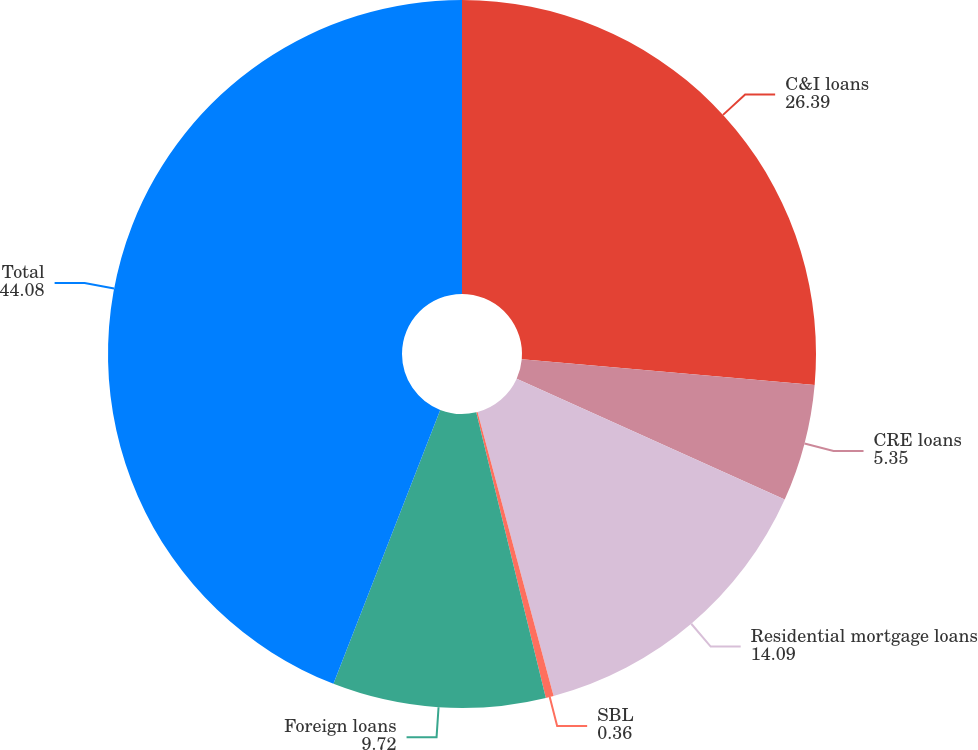Convert chart. <chart><loc_0><loc_0><loc_500><loc_500><pie_chart><fcel>C&I loans<fcel>CRE loans<fcel>Residential mortgage loans<fcel>SBL<fcel>Foreign loans<fcel>Total<nl><fcel>26.39%<fcel>5.35%<fcel>14.09%<fcel>0.36%<fcel>9.72%<fcel>44.08%<nl></chart> 